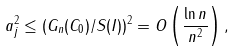<formula> <loc_0><loc_0><loc_500><loc_500>& a _ { j } ^ { 2 } \leq ( G _ { n } ( C _ { 0 } ) / S ( I ) ) ^ { 2 } = O \left ( \frac { \ln n } { n ^ { 2 } } \right ) ,</formula> 